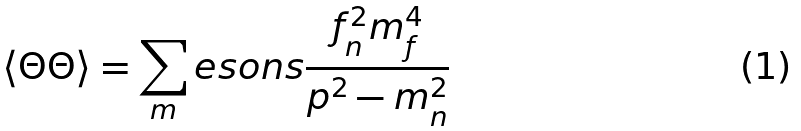Convert formula to latex. <formula><loc_0><loc_0><loc_500><loc_500>\langle \Theta \Theta \rangle = \sum _ { m } e s o n s \frac { f _ { n } ^ { 2 } m _ { f } ^ { 4 } } { p ^ { 2 } - m _ { n } ^ { 2 } }</formula> 